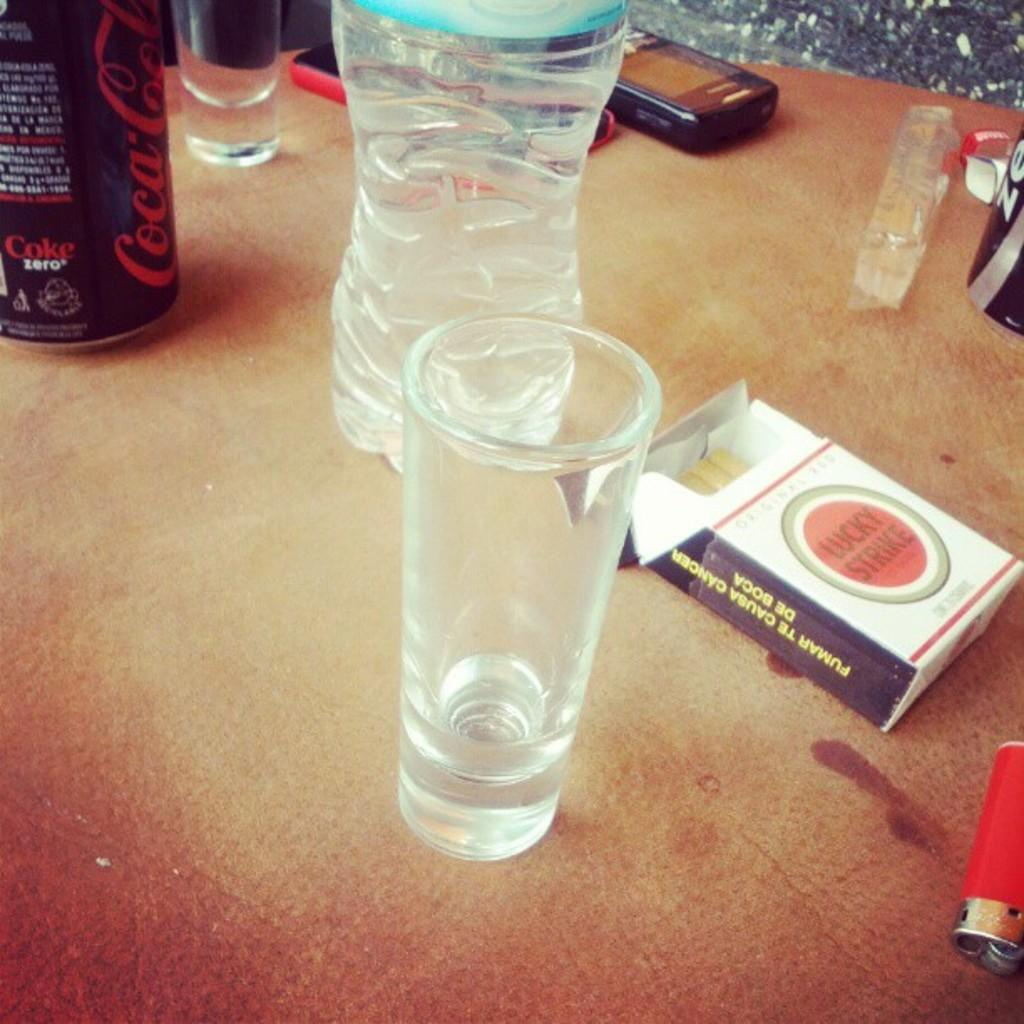<image>
Offer a succinct explanation of the picture presented. an empty shot glass next to a pack of lucky strike cigarettes 